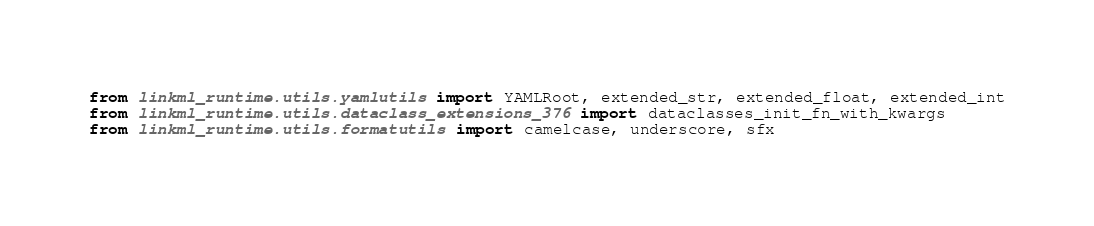<code> <loc_0><loc_0><loc_500><loc_500><_Python_>from linkml_runtime.utils.yamlutils import YAMLRoot, extended_str, extended_float, extended_int
from linkml_runtime.utils.dataclass_extensions_376 import dataclasses_init_fn_with_kwargs
from linkml_runtime.utils.formatutils import camelcase, underscore, sfx</code> 